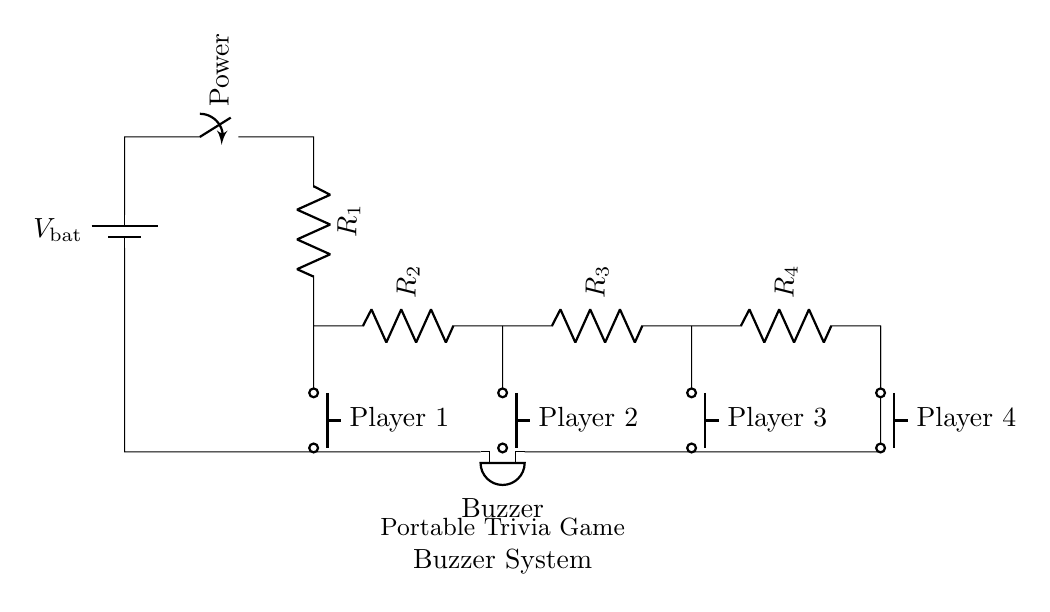What is the function of the buzzer? The buzzer produces sound when current flows through it, indicating a player's selection.
Answer: sound How many resistors are present in the circuit? There are four resistors labeled as R1, R2, R3, and R4 in the series circuit.
Answer: four What type of circuit is shown? The circuit is a series circuit because all components are connected end-to-end, forming a single path for current to flow.
Answer: series Which component connects to Player 1? The push button labeled "Player 1" connects to the resistor R1, allowing current to flow when pressed.
Answer: push button What is the role of the switch in this circuit? The switch controls the flow of power from the battery to the rest of the circuit, turning it on or off.
Answer: control If Player 3 presses their button, what would happen? If Player 3 presses their button, current flows through R3 to the buzzer, causing it to sound, indicating their selection.
Answer: buzzer sounds What is the total number of players in this trivia game? There are four push buttons, each designated for a different player.
Answer: four 